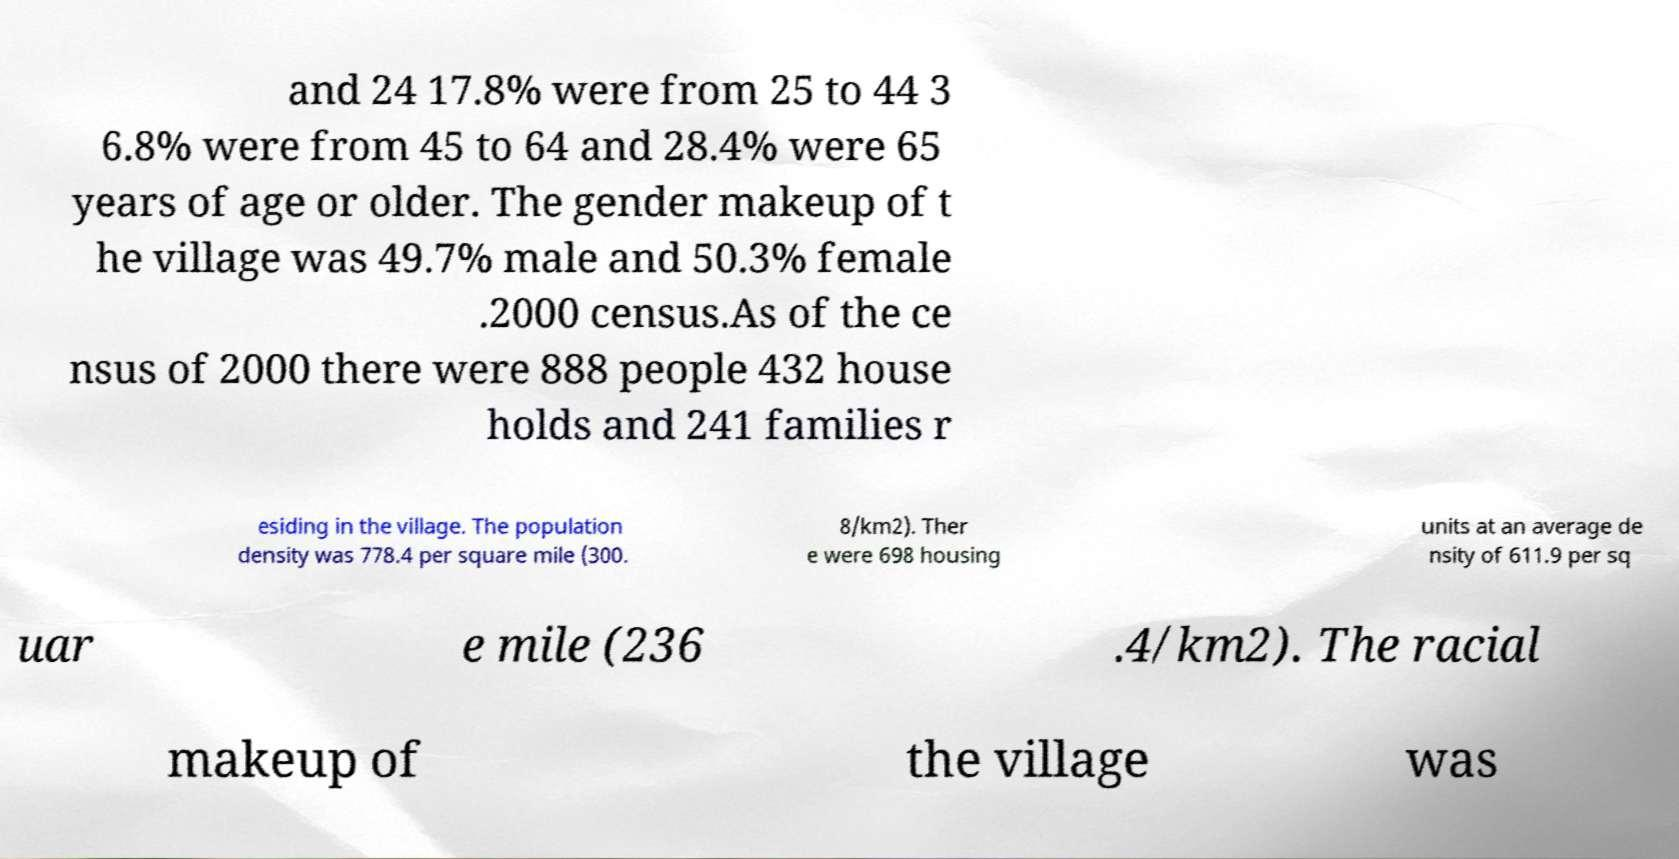There's text embedded in this image that I need extracted. Can you transcribe it verbatim? and 24 17.8% were from 25 to 44 3 6.8% were from 45 to 64 and 28.4% were 65 years of age or older. The gender makeup of t he village was 49.7% male and 50.3% female .2000 census.As of the ce nsus of 2000 there were 888 people 432 house holds and 241 families r esiding in the village. The population density was 778.4 per square mile (300. 8/km2). Ther e were 698 housing units at an average de nsity of 611.9 per sq uar e mile (236 .4/km2). The racial makeup of the village was 